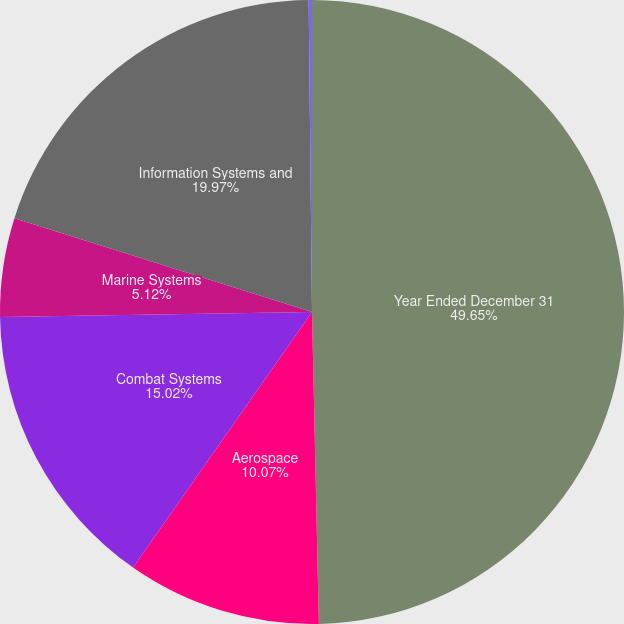<chart> <loc_0><loc_0><loc_500><loc_500><pie_chart><fcel>Year Ended December 31<fcel>Aerospace<fcel>Combat Systems<fcel>Marine Systems<fcel>Information Systems and<fcel>Corporate<nl><fcel>49.65%<fcel>10.07%<fcel>15.02%<fcel>5.12%<fcel>19.97%<fcel>0.17%<nl></chart> 